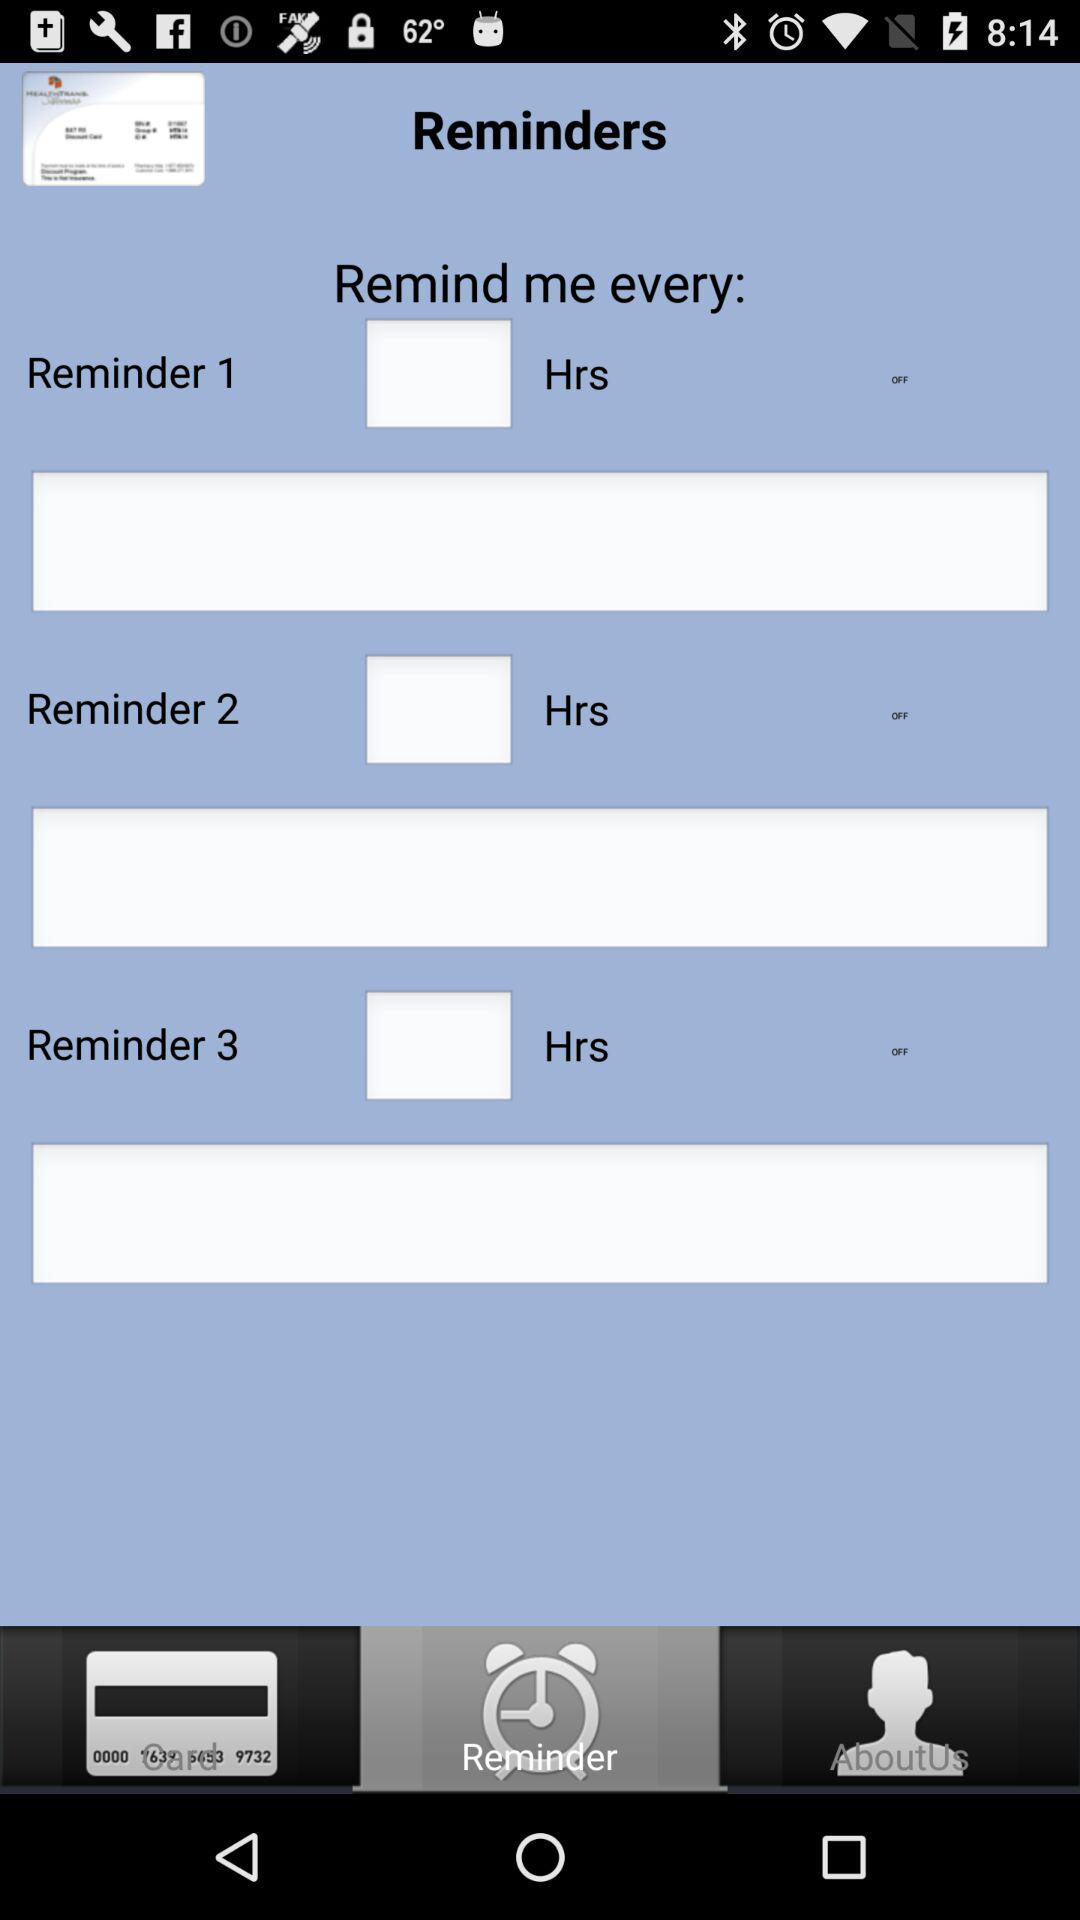How many reminder labels are there?
Answer the question using a single word or phrase. 3 